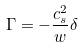<formula> <loc_0><loc_0><loc_500><loc_500>\Gamma = - \frac { c _ { s } ^ { 2 } } { w } \delta</formula> 